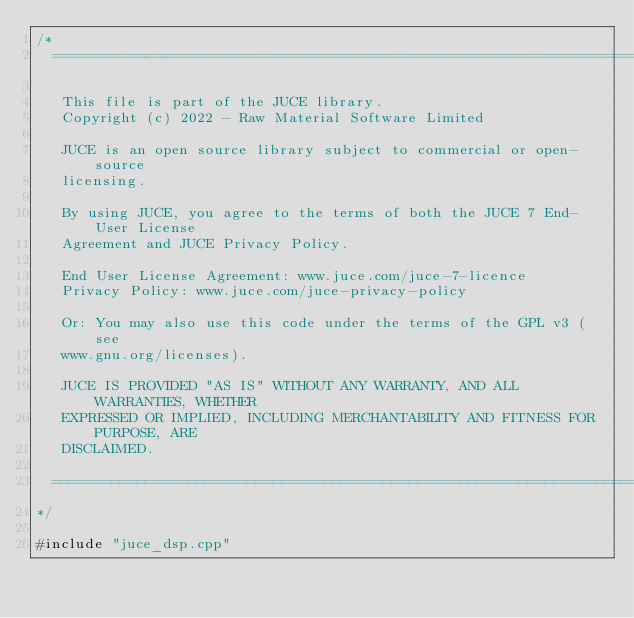<code> <loc_0><loc_0><loc_500><loc_500><_ObjectiveC_>/*
  ==============================================================================

   This file is part of the JUCE library.
   Copyright (c) 2022 - Raw Material Software Limited

   JUCE is an open source library subject to commercial or open-source
   licensing.

   By using JUCE, you agree to the terms of both the JUCE 7 End-User License
   Agreement and JUCE Privacy Policy.

   End User License Agreement: www.juce.com/juce-7-licence
   Privacy Policy: www.juce.com/juce-privacy-policy

   Or: You may also use this code under the terms of the GPL v3 (see
   www.gnu.org/licenses).

   JUCE IS PROVIDED "AS IS" WITHOUT ANY WARRANTY, AND ALL WARRANTIES, WHETHER
   EXPRESSED OR IMPLIED, INCLUDING MERCHANTABILITY AND FITNESS FOR PURPOSE, ARE
   DISCLAIMED.

  ==============================================================================
*/

#include "juce_dsp.cpp"
</code> 